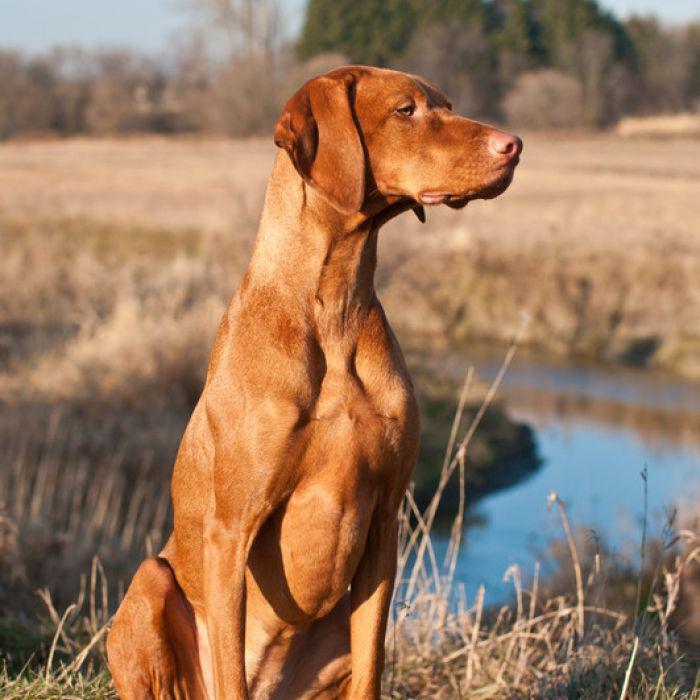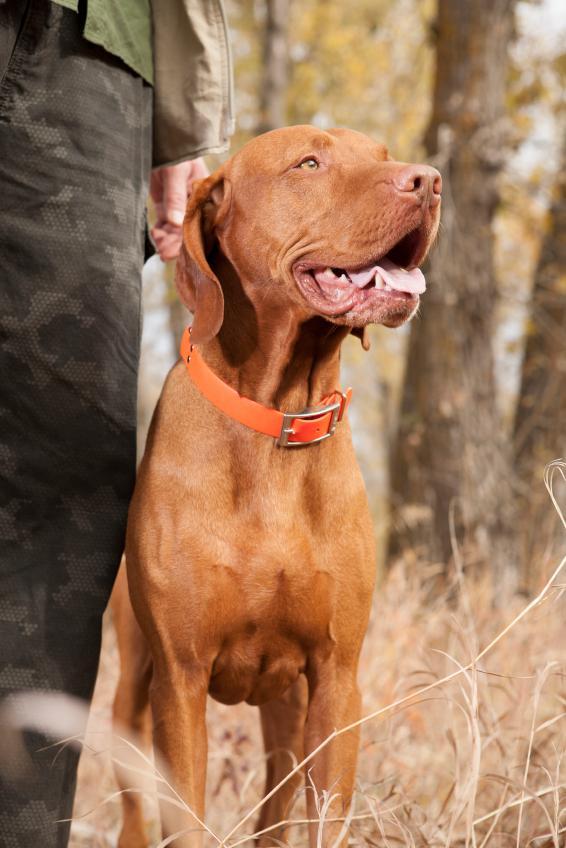The first image is the image on the left, the second image is the image on the right. Evaluate the accuracy of this statement regarding the images: "All of the brown dogs are wearing collars.". Is it true? Answer yes or no. No. The first image is the image on the left, the second image is the image on the right. Considering the images on both sides, is "There are only two dogs in the pair of images." valid? Answer yes or no. Yes. 